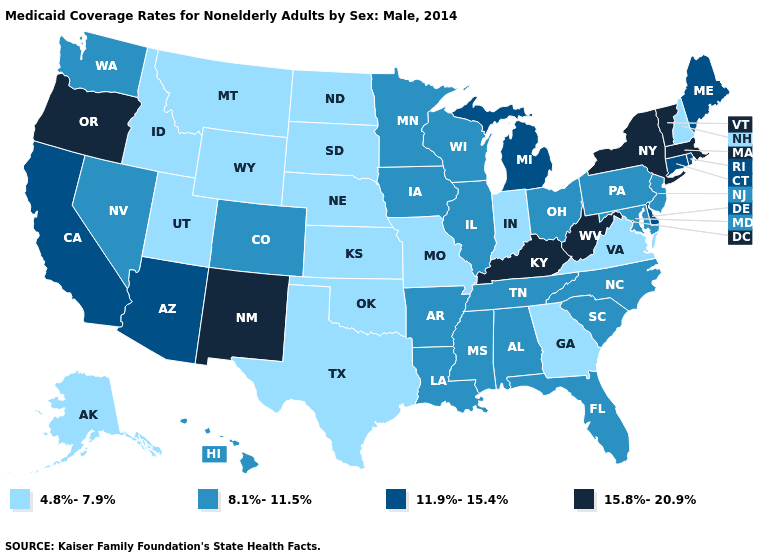Name the states that have a value in the range 4.8%-7.9%?
Concise answer only. Alaska, Georgia, Idaho, Indiana, Kansas, Missouri, Montana, Nebraska, New Hampshire, North Dakota, Oklahoma, South Dakota, Texas, Utah, Virginia, Wyoming. Which states have the lowest value in the South?
Short answer required. Georgia, Oklahoma, Texas, Virginia. Name the states that have a value in the range 4.8%-7.9%?
Concise answer only. Alaska, Georgia, Idaho, Indiana, Kansas, Missouri, Montana, Nebraska, New Hampshire, North Dakota, Oklahoma, South Dakota, Texas, Utah, Virginia, Wyoming. What is the value of Oregon?
Give a very brief answer. 15.8%-20.9%. What is the lowest value in states that border Georgia?
Keep it brief. 8.1%-11.5%. Name the states that have a value in the range 15.8%-20.9%?
Be succinct. Kentucky, Massachusetts, New Mexico, New York, Oregon, Vermont, West Virginia. Among the states that border Maine , which have the highest value?
Be succinct. New Hampshire. Name the states that have a value in the range 11.9%-15.4%?
Quick response, please. Arizona, California, Connecticut, Delaware, Maine, Michigan, Rhode Island. Among the states that border New Mexico , does Colorado have the lowest value?
Concise answer only. No. What is the lowest value in the USA?
Short answer required. 4.8%-7.9%. Name the states that have a value in the range 4.8%-7.9%?
Short answer required. Alaska, Georgia, Idaho, Indiana, Kansas, Missouri, Montana, Nebraska, New Hampshire, North Dakota, Oklahoma, South Dakota, Texas, Utah, Virginia, Wyoming. Name the states that have a value in the range 11.9%-15.4%?
Write a very short answer. Arizona, California, Connecticut, Delaware, Maine, Michigan, Rhode Island. Among the states that border Virginia , does Maryland have the highest value?
Concise answer only. No. Name the states that have a value in the range 8.1%-11.5%?
Write a very short answer. Alabama, Arkansas, Colorado, Florida, Hawaii, Illinois, Iowa, Louisiana, Maryland, Minnesota, Mississippi, Nevada, New Jersey, North Carolina, Ohio, Pennsylvania, South Carolina, Tennessee, Washington, Wisconsin. 